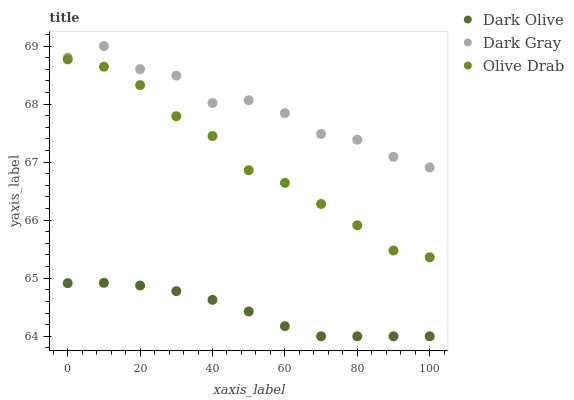Does Dark Olive have the minimum area under the curve?
Answer yes or no. Yes. Does Dark Gray have the maximum area under the curve?
Answer yes or no. Yes. Does Olive Drab have the minimum area under the curve?
Answer yes or no. No. Does Olive Drab have the maximum area under the curve?
Answer yes or no. No. Is Dark Olive the smoothest?
Answer yes or no. Yes. Is Dark Gray the roughest?
Answer yes or no. Yes. Is Olive Drab the smoothest?
Answer yes or no. No. Is Olive Drab the roughest?
Answer yes or no. No. Does Dark Olive have the lowest value?
Answer yes or no. Yes. Does Olive Drab have the lowest value?
Answer yes or no. No. Does Dark Gray have the highest value?
Answer yes or no. Yes. Does Olive Drab have the highest value?
Answer yes or no. No. Is Olive Drab less than Dark Gray?
Answer yes or no. Yes. Is Olive Drab greater than Dark Olive?
Answer yes or no. Yes. Does Olive Drab intersect Dark Gray?
Answer yes or no. No. 